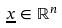<formula> <loc_0><loc_0><loc_500><loc_500>\underline { x } \in \mathbb { R } ^ { n }</formula> 